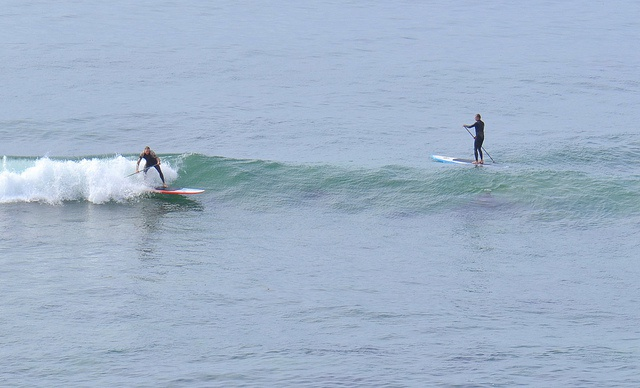Describe the objects in this image and their specific colors. I can see people in lightblue, black, gray, darkgray, and lightgray tones, surfboard in lightblue, darkgray, and lightgray tones, people in lightblue, black, navy, gray, and darkgray tones, and surfboard in lightblue, lavender, gray, and lightpink tones in this image. 